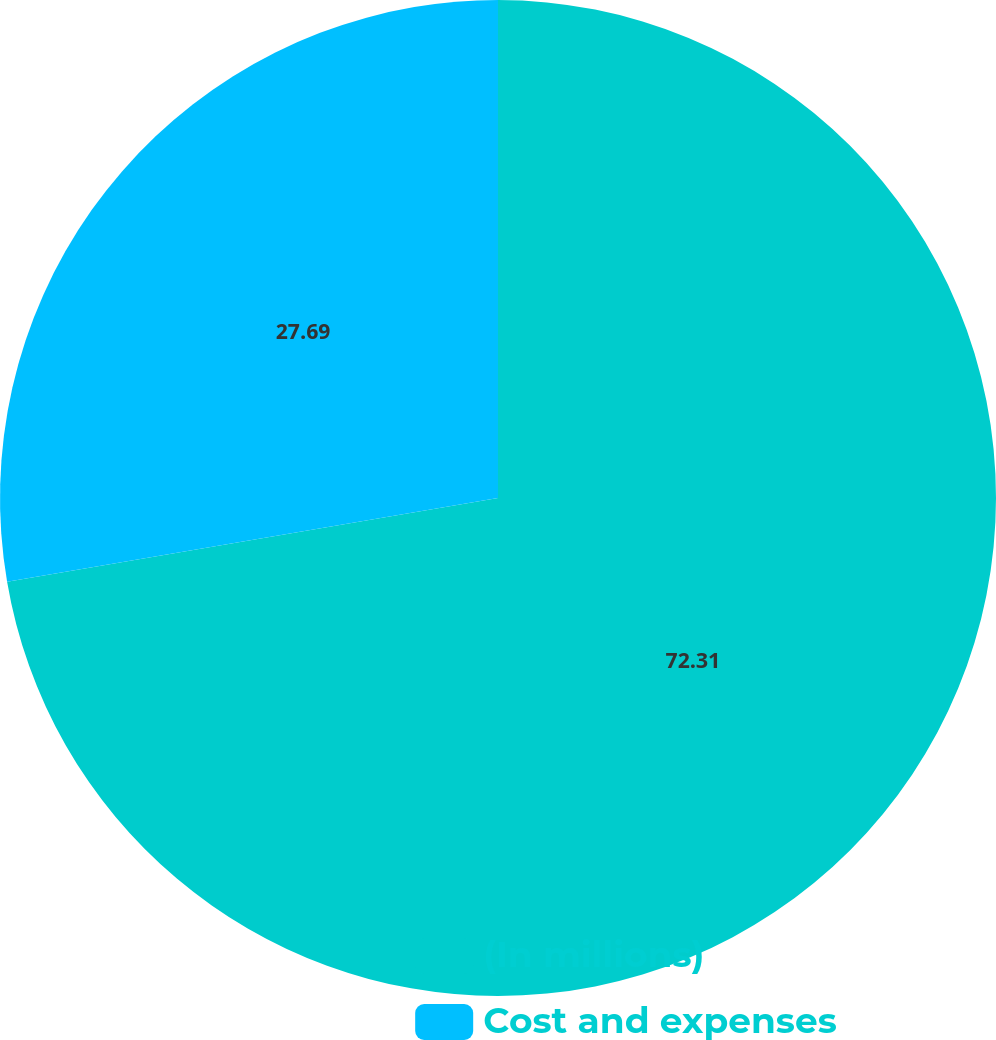<chart> <loc_0><loc_0><loc_500><loc_500><pie_chart><fcel>(In millions)<fcel>Cost and expenses<nl><fcel>72.31%<fcel>27.69%<nl></chart> 